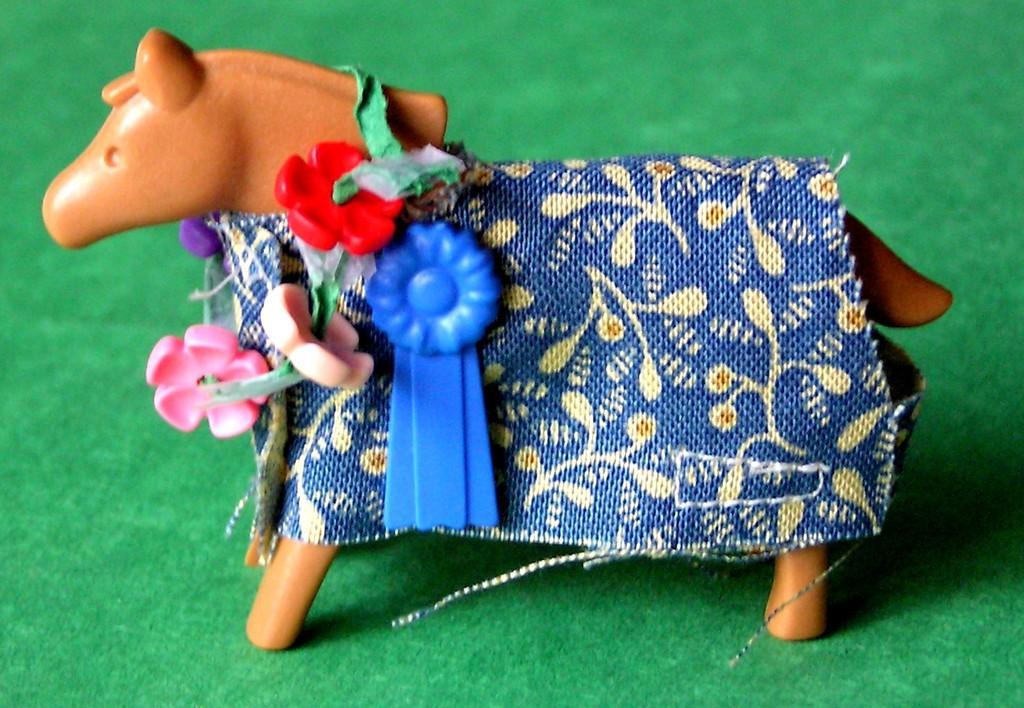Could you give a brief overview of what you see in this image? This is a toy horse, which is decorated with a cloth and few other things. I think this is a carpet, which is green in color. 